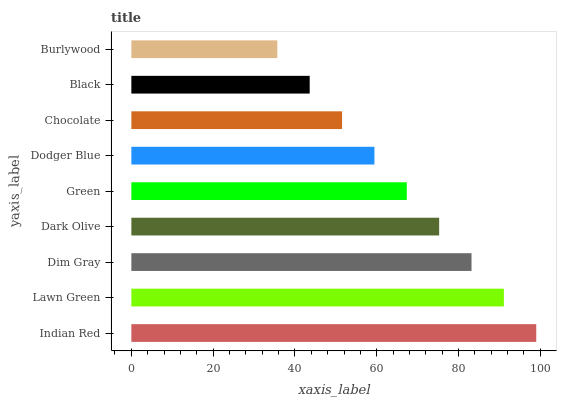Is Burlywood the minimum?
Answer yes or no. Yes. Is Indian Red the maximum?
Answer yes or no. Yes. Is Lawn Green the minimum?
Answer yes or no. No. Is Lawn Green the maximum?
Answer yes or no. No. Is Indian Red greater than Lawn Green?
Answer yes or no. Yes. Is Lawn Green less than Indian Red?
Answer yes or no. Yes. Is Lawn Green greater than Indian Red?
Answer yes or no. No. Is Indian Red less than Lawn Green?
Answer yes or no. No. Is Green the high median?
Answer yes or no. Yes. Is Green the low median?
Answer yes or no. Yes. Is Burlywood the high median?
Answer yes or no. No. Is Dark Olive the low median?
Answer yes or no. No. 